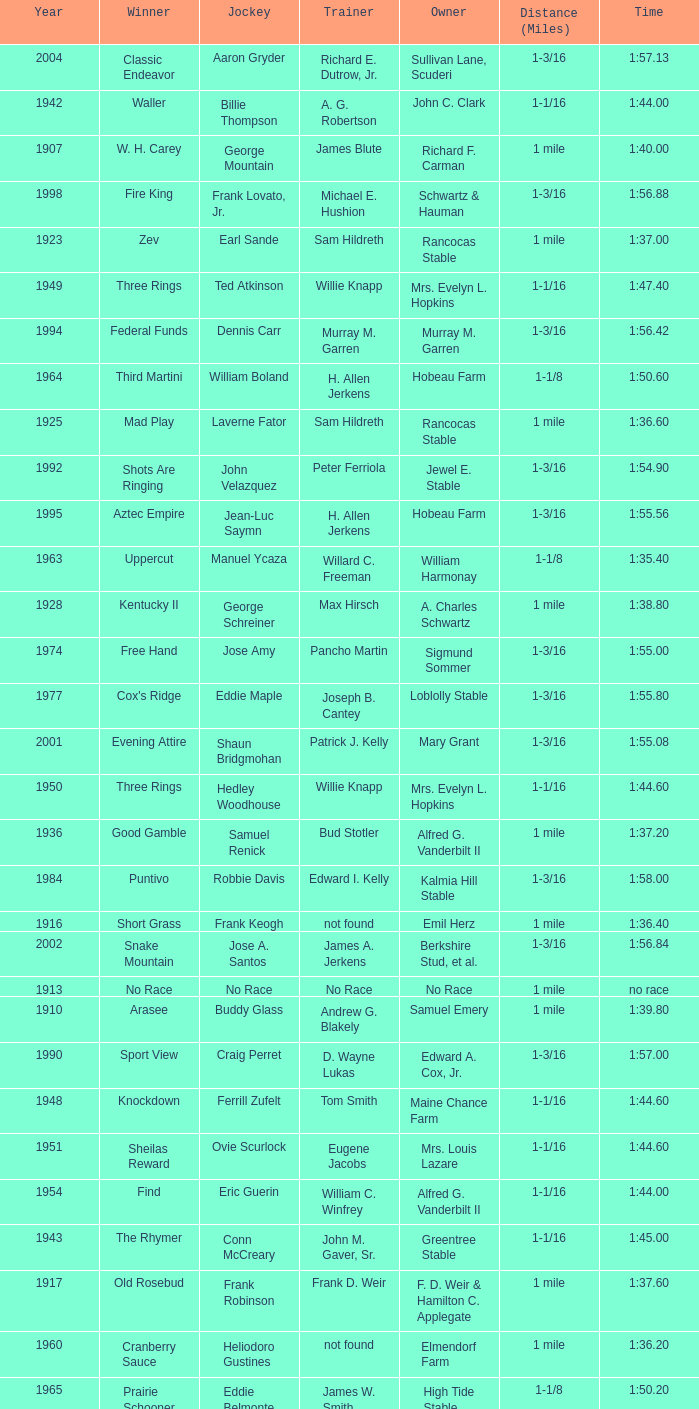What was the winning time for the winning horse, Kentucky ii? 1:38.80. 